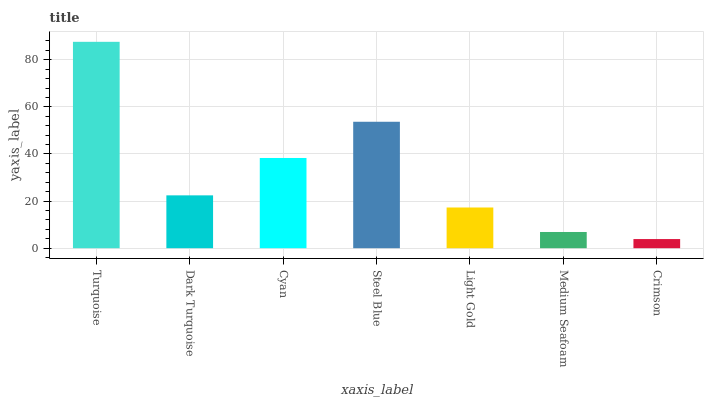Is Crimson the minimum?
Answer yes or no. Yes. Is Turquoise the maximum?
Answer yes or no. Yes. Is Dark Turquoise the minimum?
Answer yes or no. No. Is Dark Turquoise the maximum?
Answer yes or no. No. Is Turquoise greater than Dark Turquoise?
Answer yes or no. Yes. Is Dark Turquoise less than Turquoise?
Answer yes or no. Yes. Is Dark Turquoise greater than Turquoise?
Answer yes or no. No. Is Turquoise less than Dark Turquoise?
Answer yes or no. No. Is Dark Turquoise the high median?
Answer yes or no. Yes. Is Dark Turquoise the low median?
Answer yes or no. Yes. Is Light Gold the high median?
Answer yes or no. No. Is Medium Seafoam the low median?
Answer yes or no. No. 